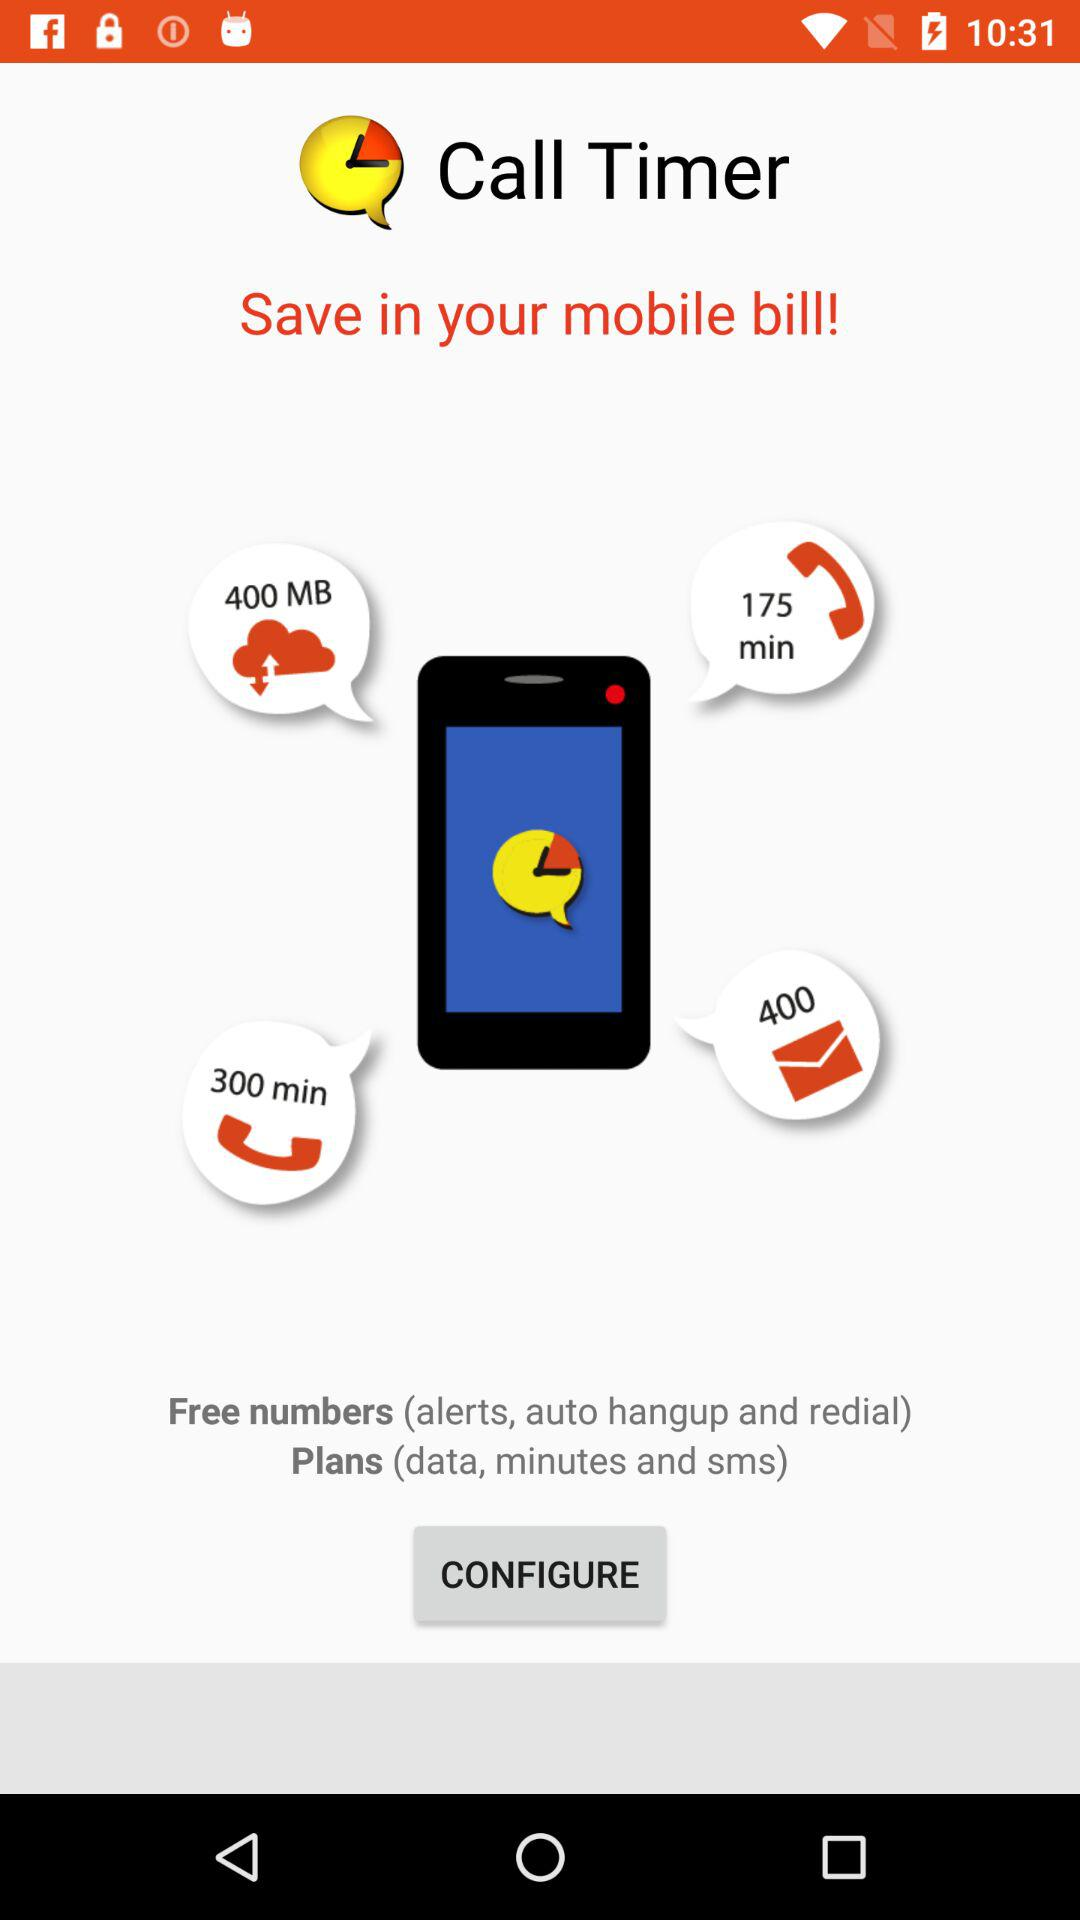How many more minutes are included in the 300 minute plan than the 175 minute plan?
Answer the question using a single word or phrase. 125 